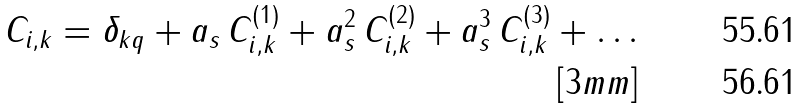Convert formula to latex. <formula><loc_0><loc_0><loc_500><loc_500>C _ { i , k } = \delta _ { k q } + a _ { s } \, C ^ { ( 1 ) } _ { i , k } + a _ { s } ^ { 2 } \, C ^ { ( 2 ) } _ { i , k } + a _ { s } ^ { 3 } \, C ^ { ( 3 ) } _ { i , k } + \dots \\ [ 3 m m ]</formula> 